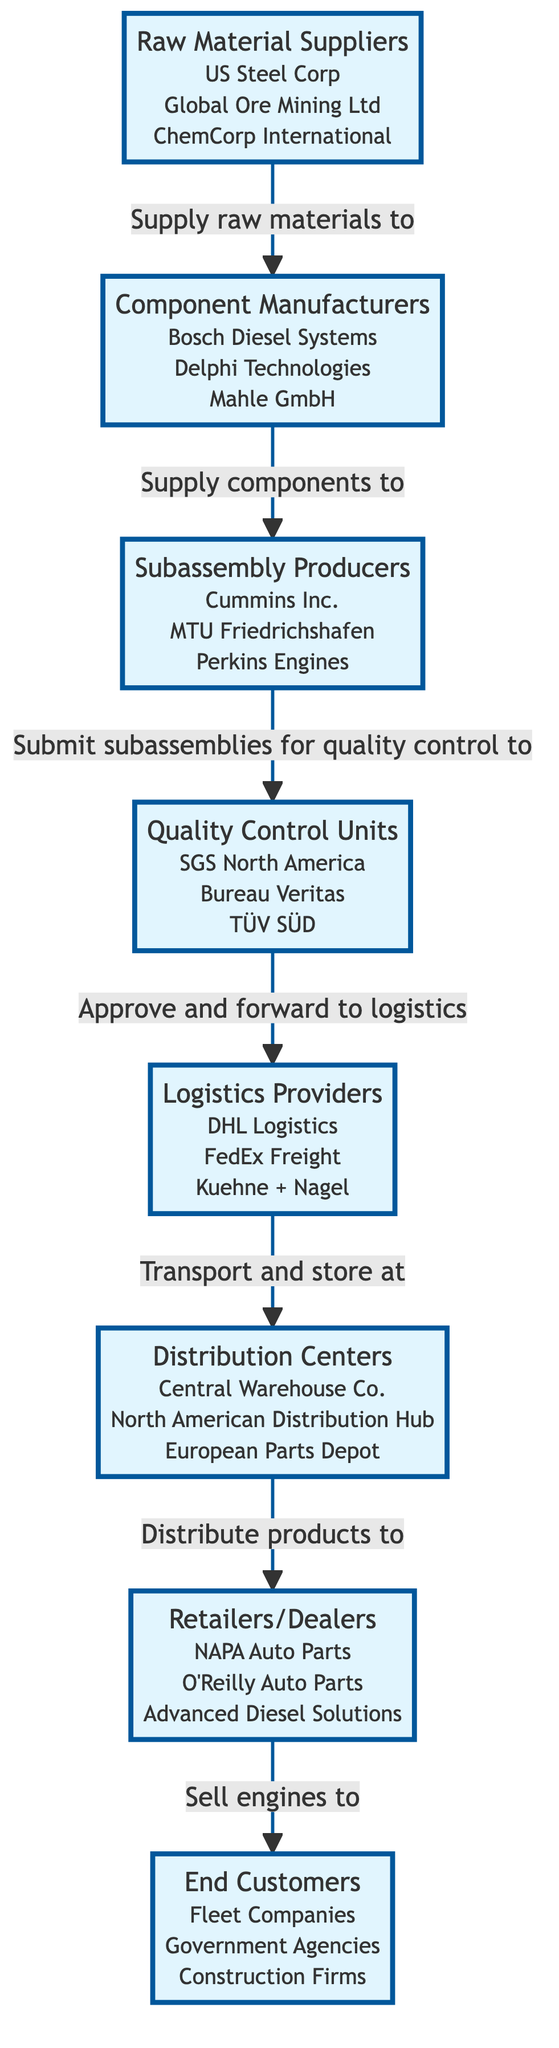What is the total number of nodes in the diagram? The diagram consists of 8 distinct nodes. Each node represents a different entity in the supply chain for diesel engine components.
Answer: 8 Which entity is connected to Quality Control Units? Quality Control Units is connected from Subassembly Producers, which submit subassemblies for quality control. The relationship indicates that subassemblies must pass through Quality Control before proceeding.
Answer: Subassembly Producers Who supplies raw materials to Component Manufacturers? Raw Material Suppliers provide the necessary raw materials to Component Manufacturers in order to manufacture the engine components.
Answer: Raw Material Suppliers What is the role of Logistics Providers in this network? Logistics Providers transport and store quality-approved components in Distribution Centers, managing the logistics operations between manufacturing and distribution.
Answer: Transport and store at What is the relationship between Distribution Centers and Retailers/Dealers? Distribution Centers distribute products to Retailers/Dealers, meaning that once stored, the components or engines are sent out to retailers for sale.
Answer: Distribute products to Identify the end customer segment mentioned in the diagram. The end customers in this supply chain network include Fleet Companies, Government Agencies, and Construction Firms, as they ultimately purchase the engines.
Answer: Fleet Companies, Government Agencies, Construction Firms How many logistics providers are listed in the diagram? There are 3 logistics providers listed in the network, each responsible for the transportation and storage of products within the supply chain.
Answer: 3 Which node comes directly after Quality Control Units in the flow? After Quality Control Units, the next node in the flow is Logistics Providers. The relationship indicates that approved products must be forwarded to this next stage in the supply chain.
Answer: Logistics Providers What process follows component manufacturing in the flow? After component manufacturing, the next step in the flow is the production of subassemblies by Subassembly Producers who receive the components from the component manufacturers.
Answer: Submit subassemblies for quality control to 